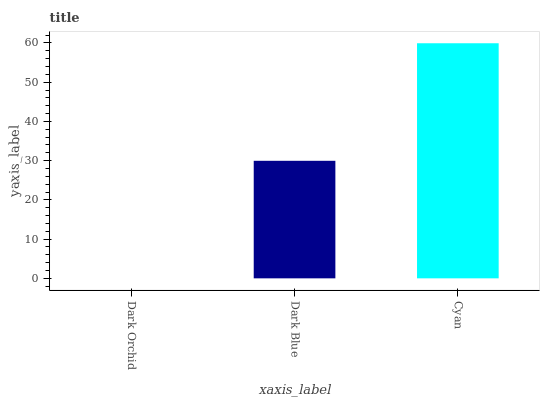Is Dark Blue the minimum?
Answer yes or no. No. Is Dark Blue the maximum?
Answer yes or no. No. Is Dark Blue greater than Dark Orchid?
Answer yes or no. Yes. Is Dark Orchid less than Dark Blue?
Answer yes or no. Yes. Is Dark Orchid greater than Dark Blue?
Answer yes or no. No. Is Dark Blue less than Dark Orchid?
Answer yes or no. No. Is Dark Blue the high median?
Answer yes or no. Yes. Is Dark Blue the low median?
Answer yes or no. Yes. Is Cyan the high median?
Answer yes or no. No. Is Dark Orchid the low median?
Answer yes or no. No. 